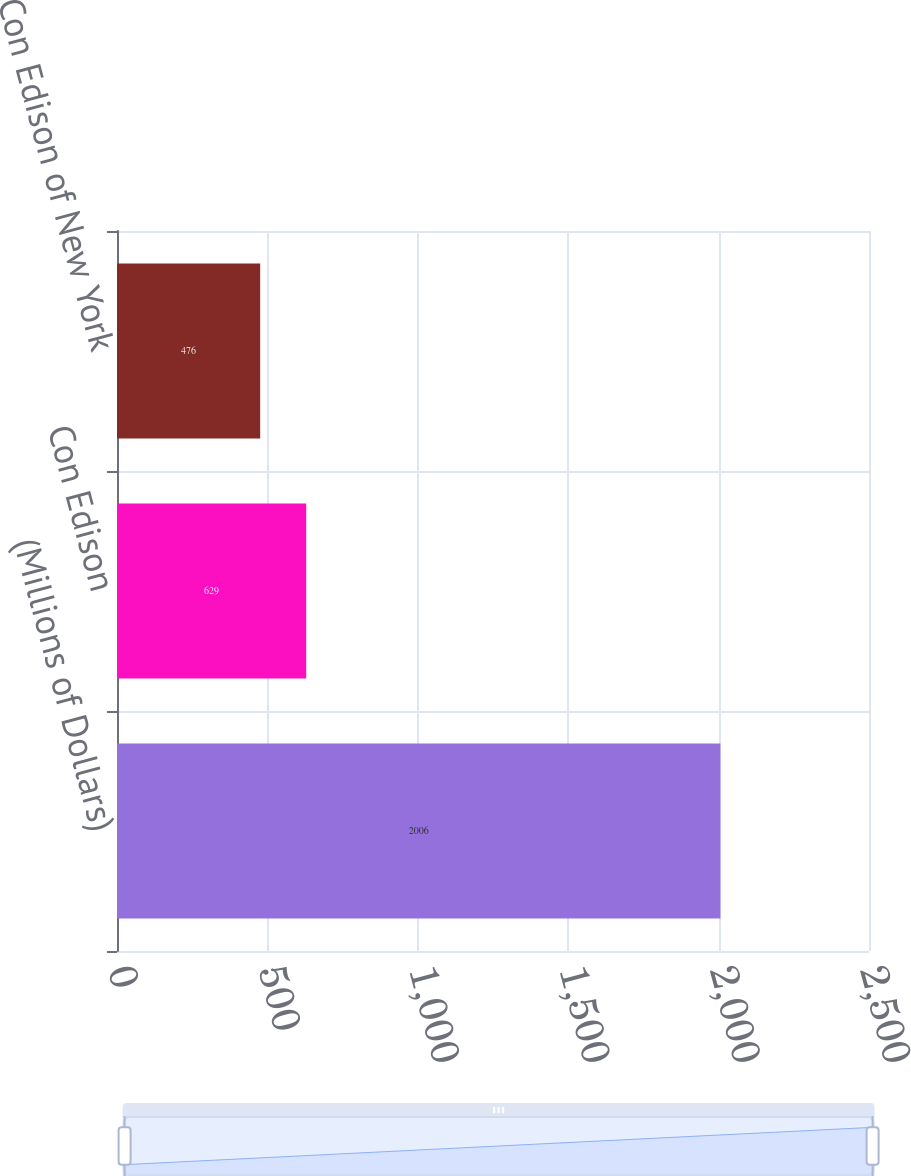Convert chart to OTSL. <chart><loc_0><loc_0><loc_500><loc_500><bar_chart><fcel>(Millions of Dollars)<fcel>Con Edison<fcel>Con Edison of New York<nl><fcel>2006<fcel>629<fcel>476<nl></chart> 